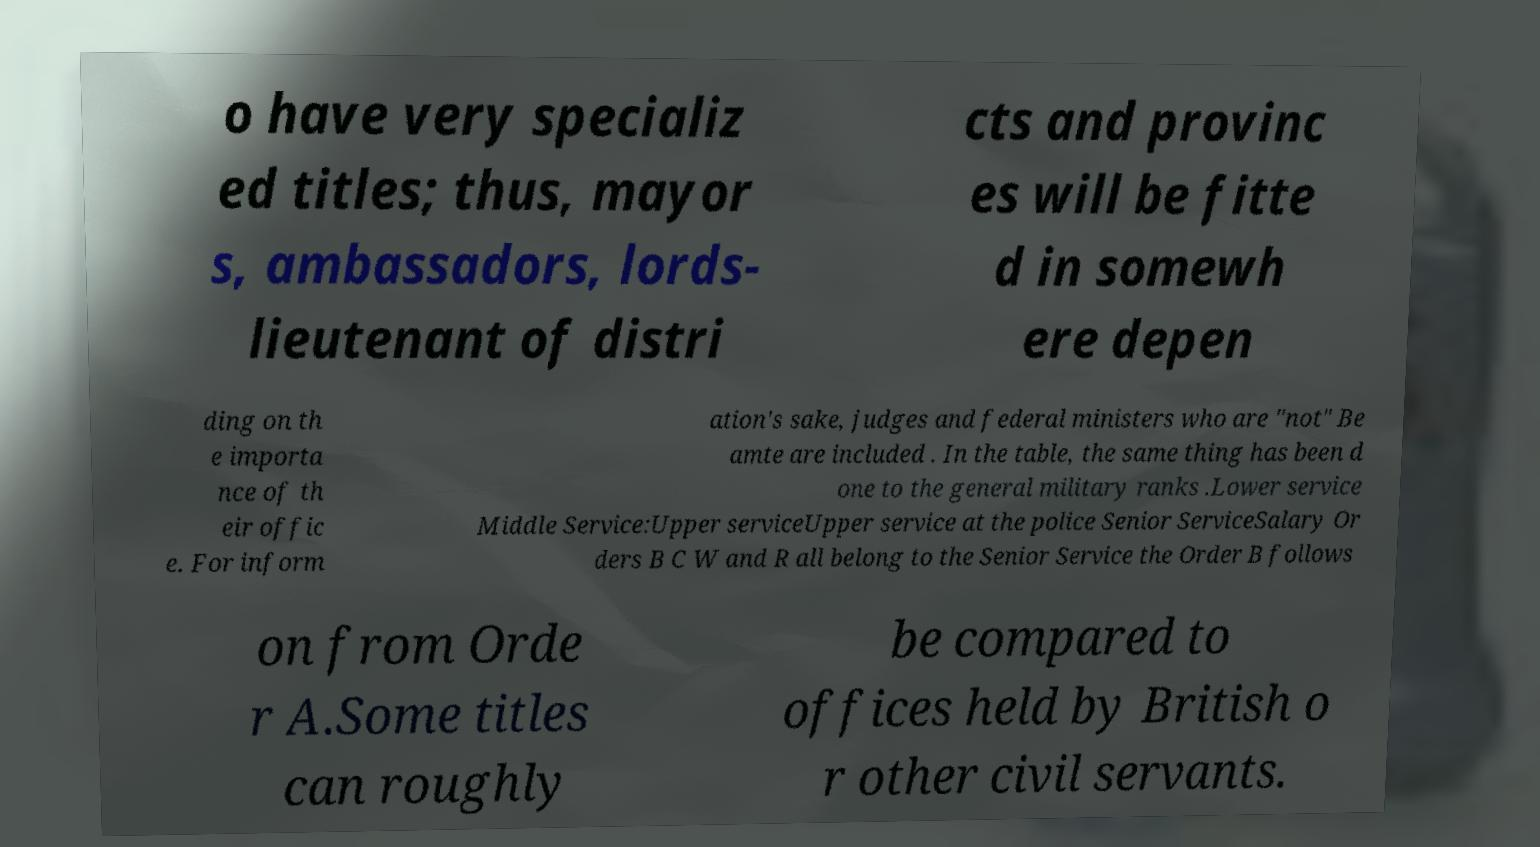Can you accurately transcribe the text from the provided image for me? o have very specializ ed titles; thus, mayor s, ambassadors, lords- lieutenant of distri cts and provinc es will be fitte d in somewh ere depen ding on th e importa nce of th eir offic e. For inform ation's sake, judges and federal ministers who are "not" Be amte are included . In the table, the same thing has been d one to the general military ranks .Lower service Middle Service:Upper serviceUpper service at the police Senior ServiceSalary Or ders B C W and R all belong to the Senior Service the Order B follows on from Orde r A.Some titles can roughly be compared to offices held by British o r other civil servants. 